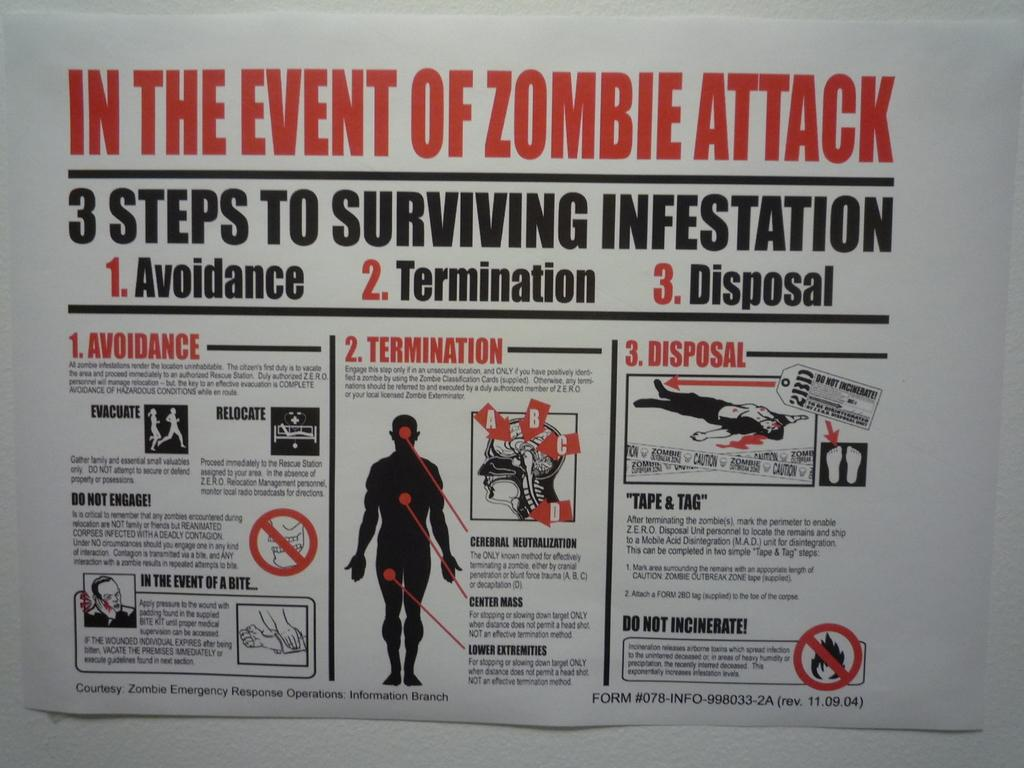<image>
Write a terse but informative summary of the picture. A printed guide to surviving a zombie attack including avoidance, termination, and disposal. 